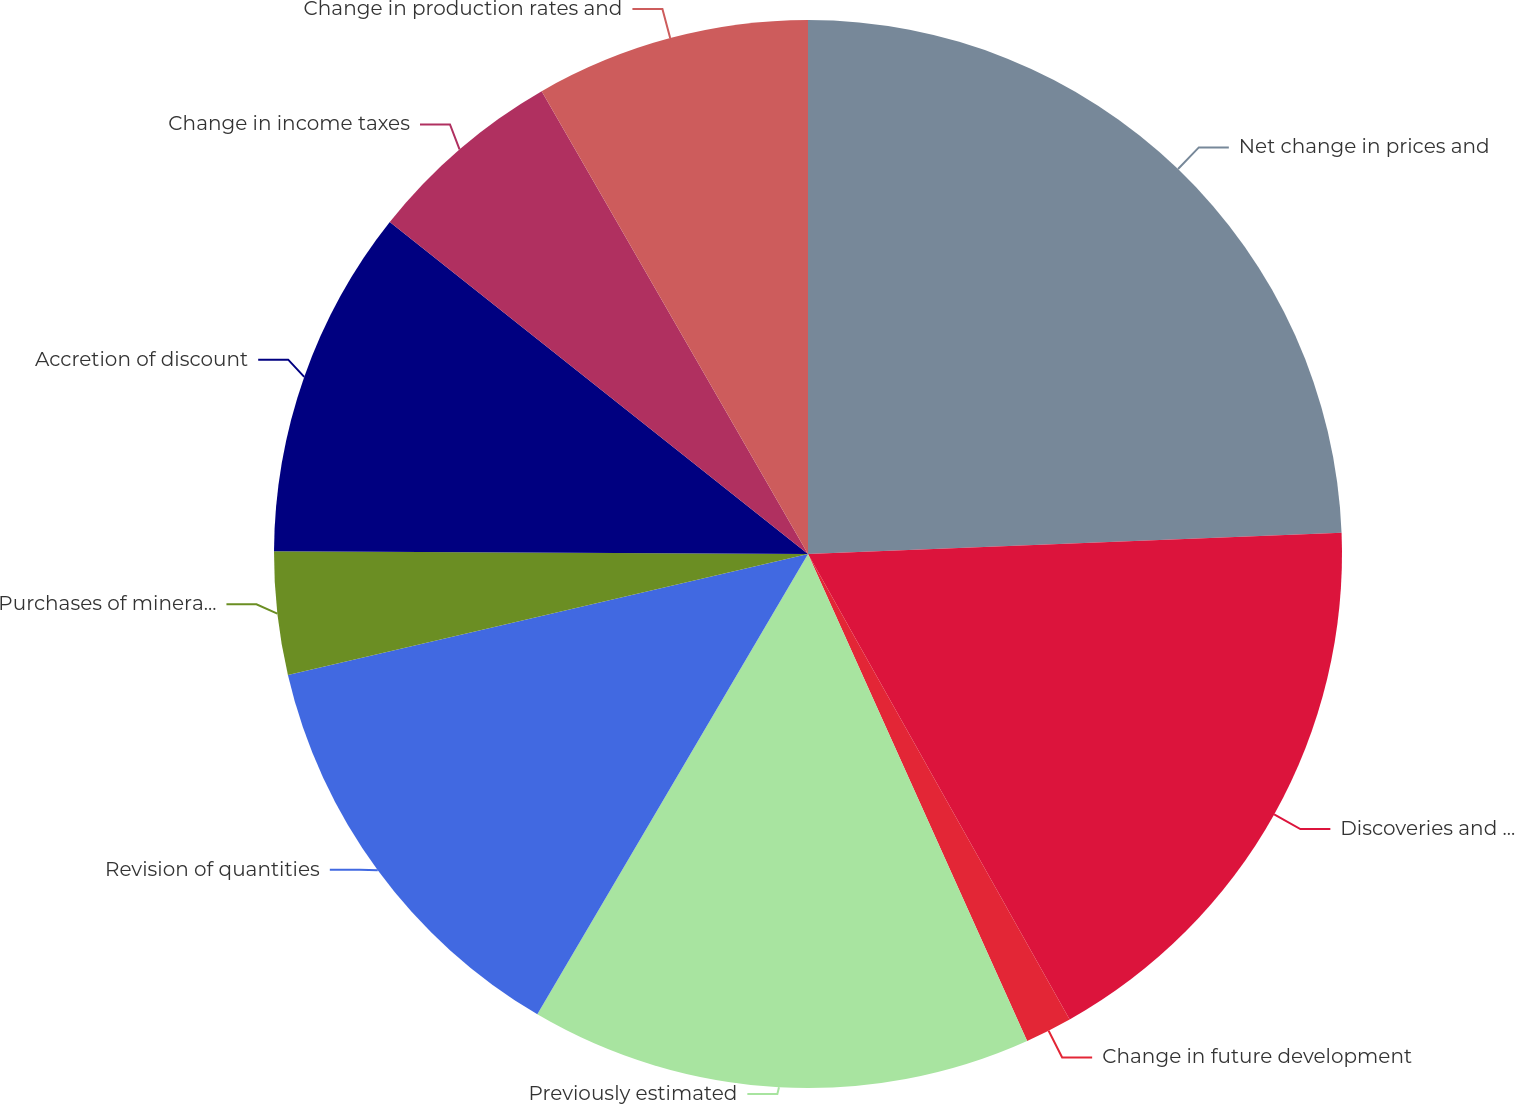<chart> <loc_0><loc_0><loc_500><loc_500><pie_chart><fcel>Net change in prices and<fcel>Discoveries and improved<fcel>Change in future development<fcel>Previously estimated<fcel>Revision of quantities<fcel>Purchases of minerals in-place<fcel>Accretion of discount<fcel>Change in income taxes<fcel>Change in production rates and<nl><fcel>24.37%<fcel>17.48%<fcel>1.42%<fcel>15.19%<fcel>12.9%<fcel>3.72%<fcel>10.6%<fcel>6.01%<fcel>8.31%<nl></chart> 